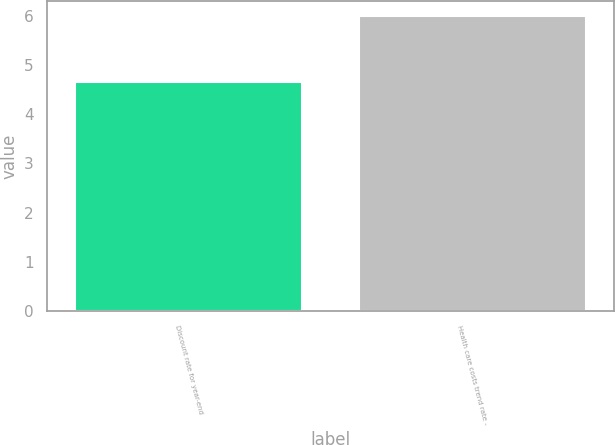Convert chart to OTSL. <chart><loc_0><loc_0><loc_500><loc_500><bar_chart><fcel>Discount rate for year-end<fcel>Health care costs trend rate -<nl><fcel>4.65<fcel>6<nl></chart> 